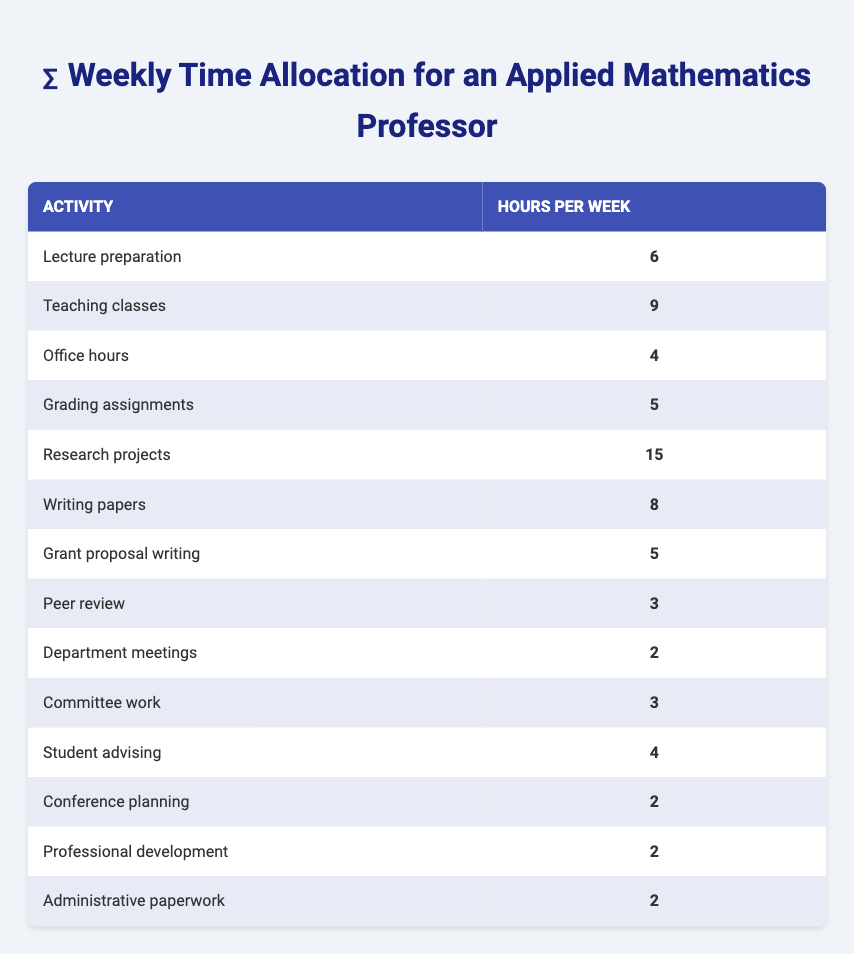What activity requires the most hours per week? Research projects require the most hours per week at 15 hours. By checking the "Hours per Week" column, I see that this value is the highest in the table.
Answer: Research projects What is the total time spent on teaching-related activities? The teaching-related activities are "Lecture preparation," "Teaching classes," "Office hours," and "Grading assignments." Adding these up gives: 6 + 9 + 4 + 5 = 24 hours.
Answer: 24 How many hours are allocated to administrative duties? The administrative duties listed are "Department meetings," "Committee work," "Conference planning," "Professional development," and "Administrative paperwork." Adding their hours gives: 2 + 3 + 2 + 2 + 2 = 11 hours.
Answer: 11 Are the hours spent on writing papers equal to the hours for peer review? Writing papers requires 8 hours, while peer review requires 3 hours. Since 8 is not equal to 3, the answer is no.
Answer: No What is the average number of hours spent on research activities? The research-related activities are "Research projects," "Writing papers," "Grant proposal writing," and "Peer review." First, summing these: 15 + 8 + 5 + 3 = 31 hours. There are 4 activities, so the average is 31/4 = 7.75 hours.
Answer: 7.75 How many more hours are devoted to teaching classes than to student advising? Teaching classes requires 9 hours, and student advising requires 4 hours. The difference is calculated as 9 - 4 = 5 hours more for teaching classes.
Answer: 5 What percentage of the total hours spent on all activities is dedicated to research projects? The total hours from the table are calculated by summing all the hours: 6 + 9 + 4 + 5 + 15 + 8 + 5 + 3 + 2 + 3 + 4 + 2 + 2 + 2 = 66 hours. The research hours are 15, so the percentage is (15/66) * 100 = 22.73%.
Answer: 22.73% Is the time allocated for office hours greater than that for committee work? Office hours take 4 hours, while committee work takes 3 hours. Since 4 is greater than 3, the answer is yes.
Answer: Yes What is the total time spent on writing-related tasks? The writing-related tasks are "Writing papers," "Grant proposal writing," and "Peer review." Adding those gives: 8 + 5 + 3 = 16 hours spent on writing-related tasks.
Answer: 16 